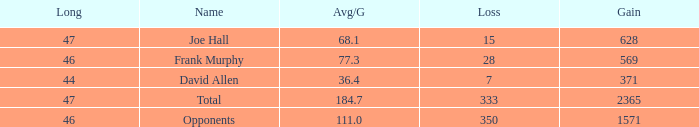Which Avg/G has a Name of david allen, and a Gain larger than 371? None. 